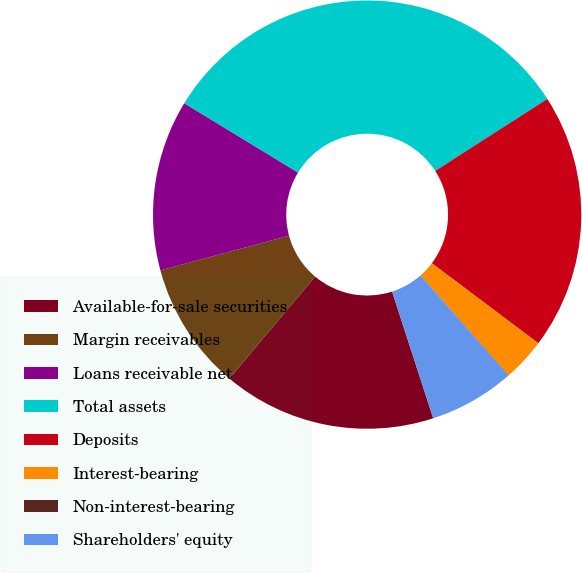Convert chart. <chart><loc_0><loc_0><loc_500><loc_500><pie_chart><fcel>Available-for-sale securities<fcel>Margin receivables<fcel>Loans receivable net<fcel>Total assets<fcel>Deposits<fcel>Interest-bearing<fcel>Non-interest-bearing<fcel>Shareholders' equity<nl><fcel>16.12%<fcel>9.68%<fcel>12.9%<fcel>32.21%<fcel>19.34%<fcel>3.25%<fcel>0.03%<fcel>6.47%<nl></chart> 